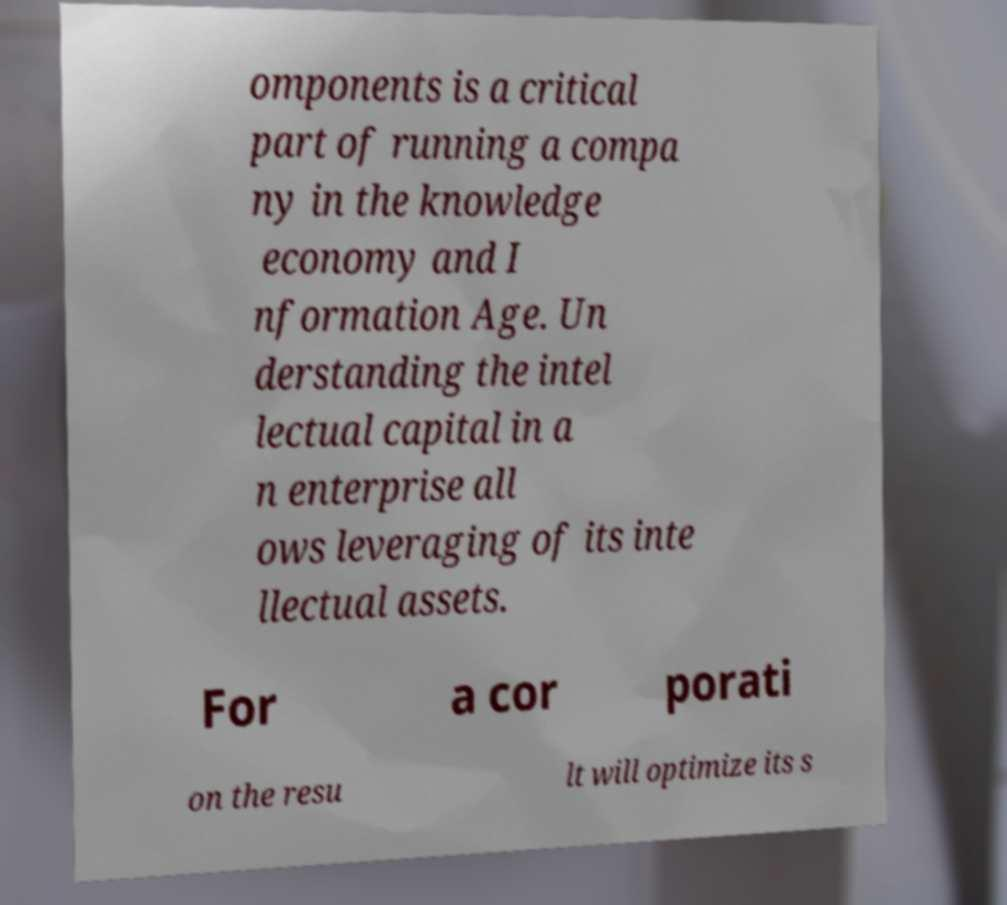For documentation purposes, I need the text within this image transcribed. Could you provide that? omponents is a critical part of running a compa ny in the knowledge economy and I nformation Age. Un derstanding the intel lectual capital in a n enterprise all ows leveraging of its inte llectual assets. For a cor porati on the resu lt will optimize its s 